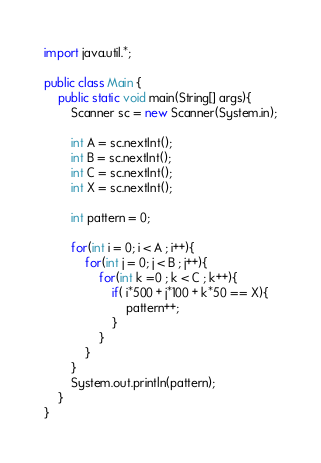<code> <loc_0><loc_0><loc_500><loc_500><_Java_>import java.util.*;

public class Main {
    public static void main(String[] args){
        Scanner sc = new Scanner(System.in);

        int A = sc.nextInt();
        int B = sc.nextInt();
        int C = sc.nextInt();
        int X = sc.nextInt();

        int pattern = 0;

        for(int i = 0; i < A ; i++){
            for(int j = 0; j < B ; j++){
                for(int k =0 ; k < C ; k++){ 
                    if( i*500 + j*100 + k*50 == X){
                        pattern++;
                    }
                }
            }
        }
        System.out.println(pattern);
    }
}</code> 